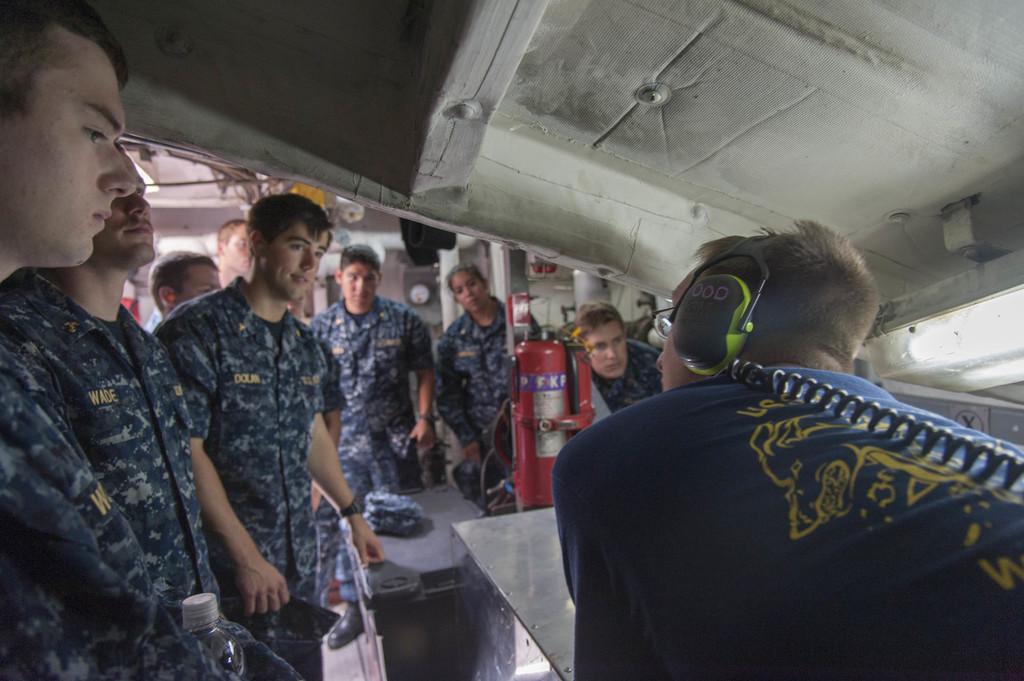In one or two sentences, can you explain what this image depicts? In this image to the right side there is a person wearing a headphone. Beside him there are few other people standing on the floor. In front of them there are two boxes and on top of it there is a fire extinguisher. 